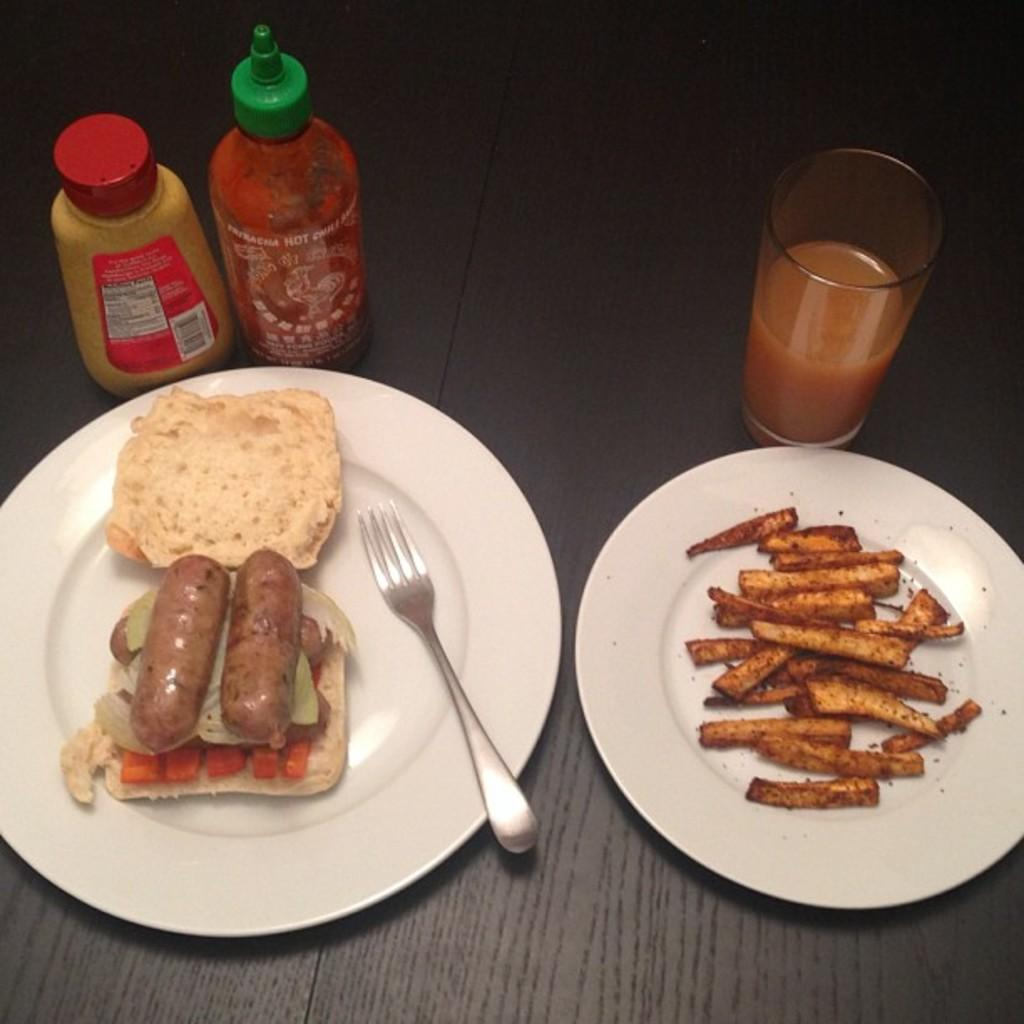What can be seen on the table in the image? There are two plates of food items on the table. What utensil is visible in the image? There is a fork visible in the image. What is being used to drink in the image? There is a glass of drink in the image. What condiment is present in the image? There is a sauce bottle in the image. What other bottle can be seen in the image? There is another bottle on the left side of the image. What type of adjustment is being made to the zinc in the image? There is no zinc present in the image, so no adjustment can be made to it. 